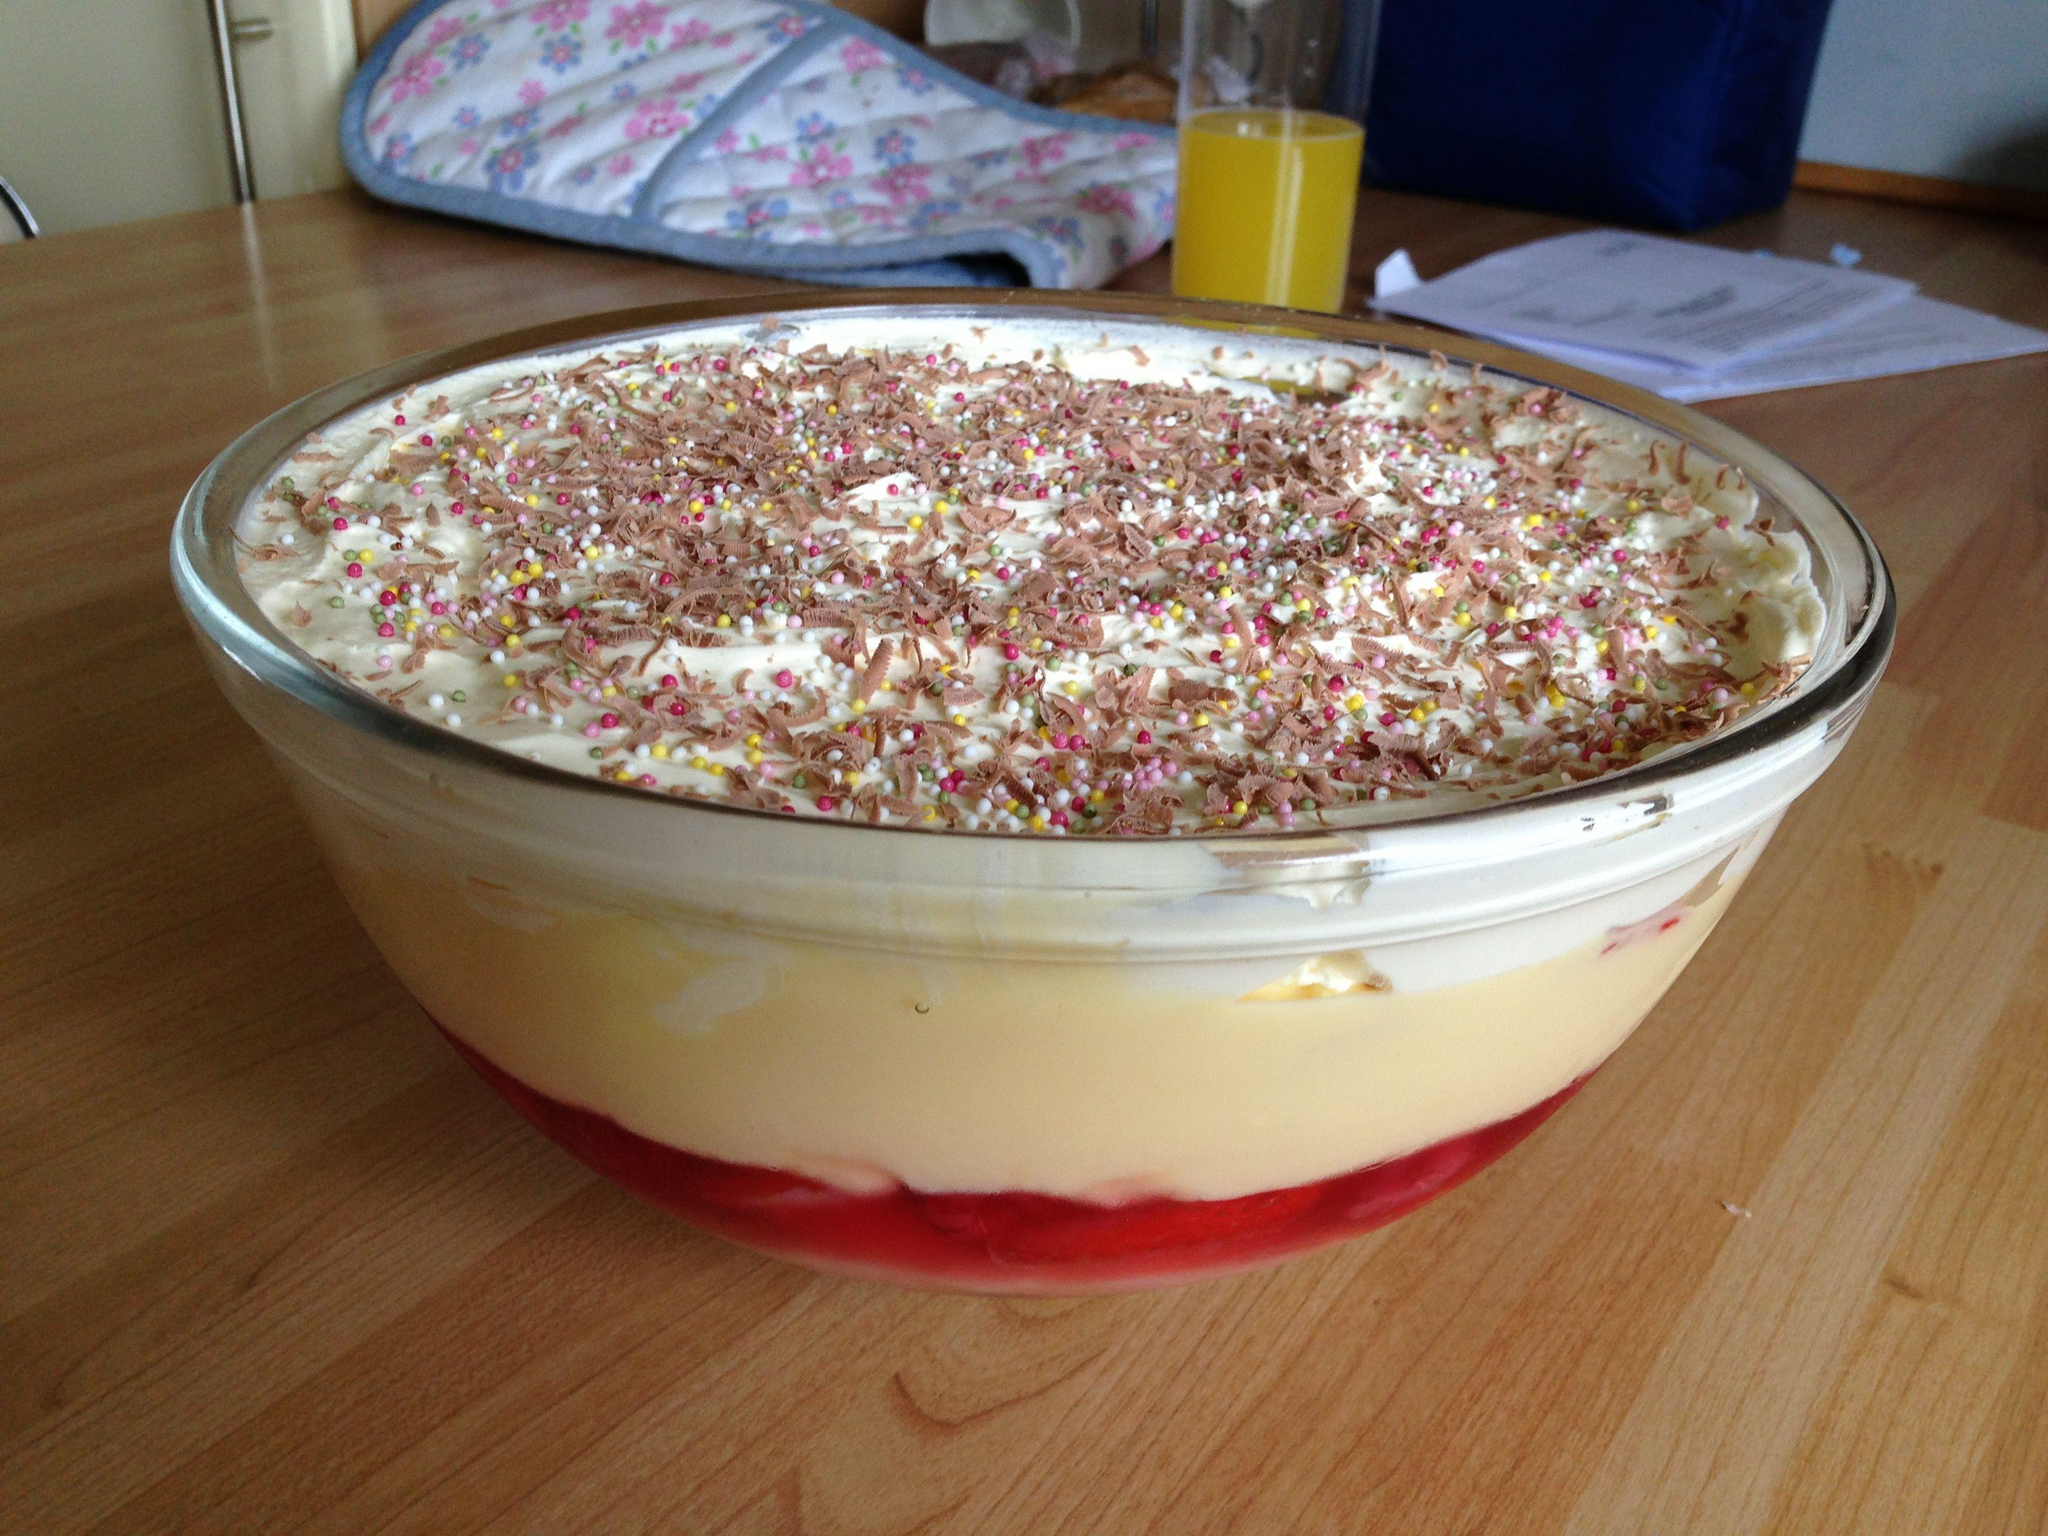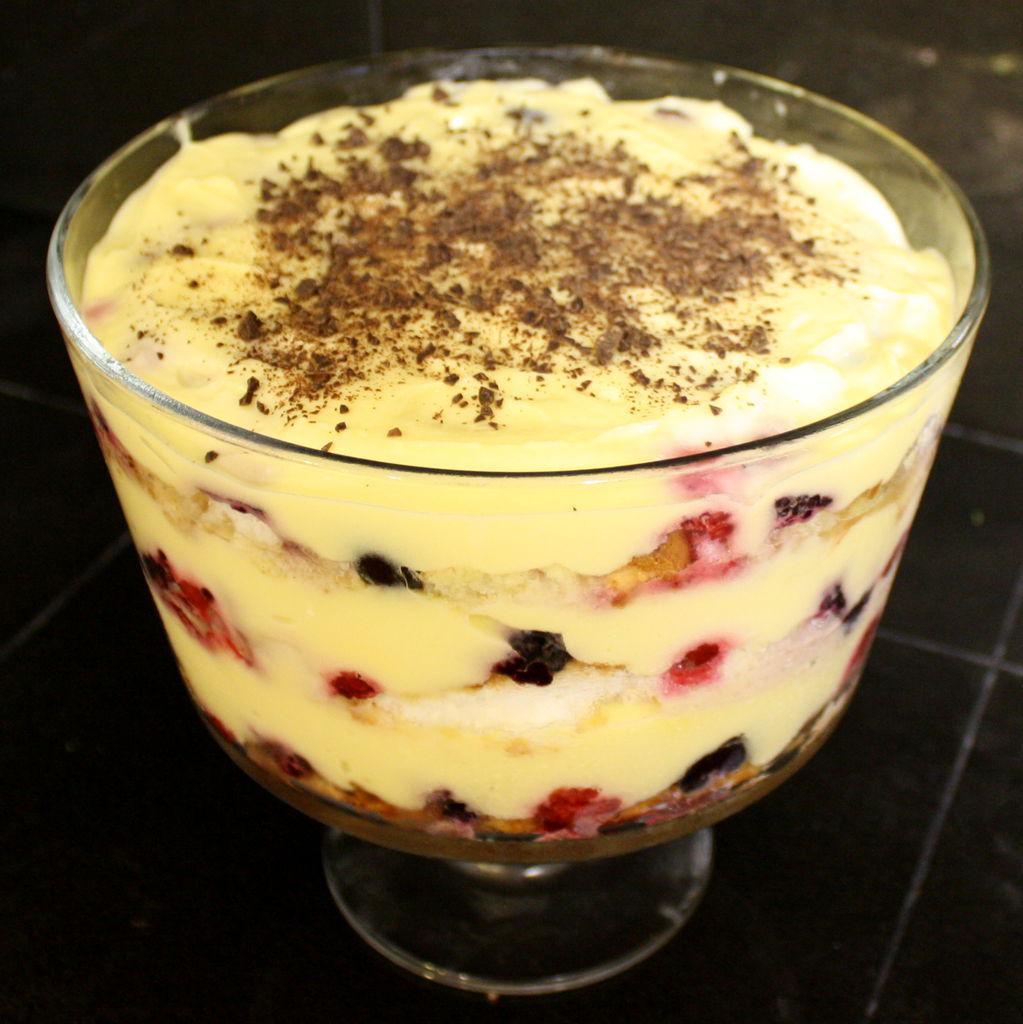The first image is the image on the left, the second image is the image on the right. Evaluate the accuracy of this statement regarding the images: "at least one trifle dessert has fruit on top". Is it true? Answer yes or no. No. 